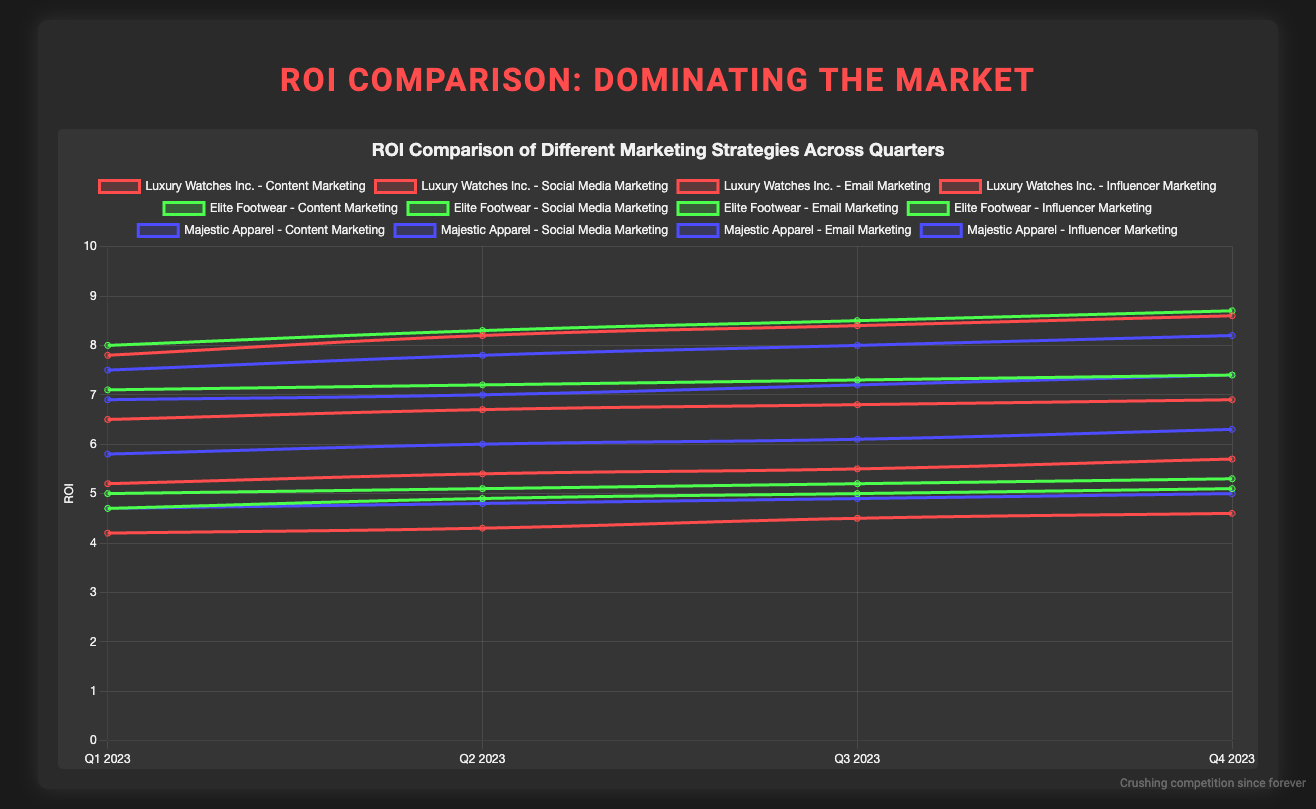Which company had the highest ROI in Influencer Marketing in Q4 2023? In the figure, look for the line representing Influencer Marketing in Q4 2023. Identify the point with the highest value among the companies. Elite Footwear has the highest ROI at 8.7.
Answer: Elite Footwear How did the ROI for Social Media Marketing at Elite Footwear change from Q1 2023 to Q4 2023? Observe the ROI for Social Media Marketing for Elite Footwear in both Q1 and Q4 2023. The value in Q1 is 7.1, and in Q4 it is 7.4. Calculate the difference: 7.4 - 7.1 = 0.3.
Answer: Increased by 0.3 What’s the average ROI for Content Marketing at Majestic Apparel across all four quarters of 2023? Add the ROI values for Content Marketing at Majestic Apparel for all four quarters: 5.8, 6.0, 6.1, 6.3. The total is 24.2. Divide by the number of quarters: 24.2/4 = 6.05.
Answer: 6.05 Compare the ROI of Email Marketing for Luxury Watches Inc. in Q1 and Q4 2023. Which has a higher value? Check the ROI for Email Marketing for Luxury Watches Inc. in Q1 and Q4 2023. Q1 has 4.2, and Q4 has 4.6. Compare the two values: 4.6 is higher than 4.2.
Answer: Q4 2023 Which marketing strategy showed a consistent increase in ROI for Luxury Watches Inc. across all quarters? Examine the lines representing different marketing strategies for Luxury Watches Inc. Look for a line that consistently rises in value across Q1 to Q4. Influencer Marketing shows such a trend with values increasing from 7.8, 8.2, 8.4 to 8.6.
Answer: Influencer Marketing What was the trend in ROI for Elite Footwear’s Email Marketing from Q1 to Q4 of 2023? Identify the trend by noting the ROI values for Email Marketing at Elite Footwear from Q1 to Q4: 5.0, 5.1, 5.2, and 5.3. The trend is an incremental increase each quarter.
Answer: Increasing Calculate the difference in ROI between Content Marketing and Social Media Marketing for Majestic Apparel in Q3 2023. Note the ROI for Content Marketing (6.1) and Social Media Marketing (7.2) at Majestic Apparel in Q3 2023. Subtract the lower from the higher: 7.2 - 6.1 = 1.1.
Answer: 1.1 Which company had the most stable ROI in Content Marketing throughout 2023, and what was the standard deviation? Identify the ROI values of Content Marketing for each company across all quarters. Calculate the standard deviation for Luxury Watches Inc. (5.2, 5.4, 5.5, 5.7), Elite Footwear (4.7, 4.9, 5.0, 5.1), and Majestic Apparel (5.8, 6.0, 6.1, 6.3). Elite Footwear has values with the smallest range and variation. The standard deviation (√variance) is calculated from these values.
Answer: Elite Footwear (0.17) Among the three companies, which one had the highest average ROI in Social Media Marketing in 2023? Calculate the average ROI for Social Media Marketing for each company. Luxury Watches Inc.: (6.5 + 6.7 + 6.8 + 6.9)/4 = 6.725; Elite Footwear: (7.1 + 7.2 + 7.3 + 7.4)/4 = 7.25; Majestic Apparel: (6.9 + 7.0 + 7.2 + 7.4)/4 = 7.125. Elite Footwear has the highest average.
Answer: Elite Footwear 